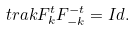<formula> <loc_0><loc_0><loc_500><loc_500>\ t r a k { F _ { k } ^ { t } } F _ { - k } ^ { - t } = I d .</formula> 